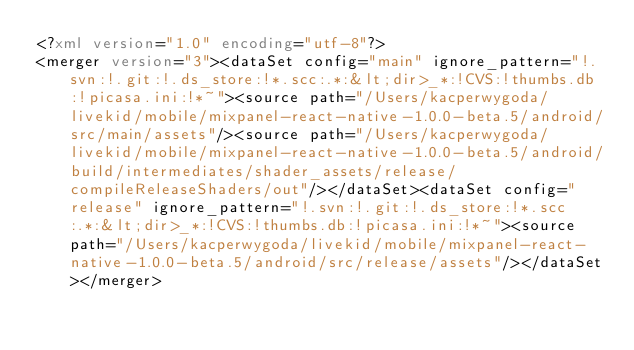<code> <loc_0><loc_0><loc_500><loc_500><_XML_><?xml version="1.0" encoding="utf-8"?>
<merger version="3"><dataSet config="main" ignore_pattern="!.svn:!.git:!.ds_store:!*.scc:.*:&lt;dir>_*:!CVS:!thumbs.db:!picasa.ini:!*~"><source path="/Users/kacperwygoda/livekid/mobile/mixpanel-react-native-1.0.0-beta.5/android/src/main/assets"/><source path="/Users/kacperwygoda/livekid/mobile/mixpanel-react-native-1.0.0-beta.5/android/build/intermediates/shader_assets/release/compileReleaseShaders/out"/></dataSet><dataSet config="release" ignore_pattern="!.svn:!.git:!.ds_store:!*.scc:.*:&lt;dir>_*:!CVS:!thumbs.db:!picasa.ini:!*~"><source path="/Users/kacperwygoda/livekid/mobile/mixpanel-react-native-1.0.0-beta.5/android/src/release/assets"/></dataSet></merger></code> 